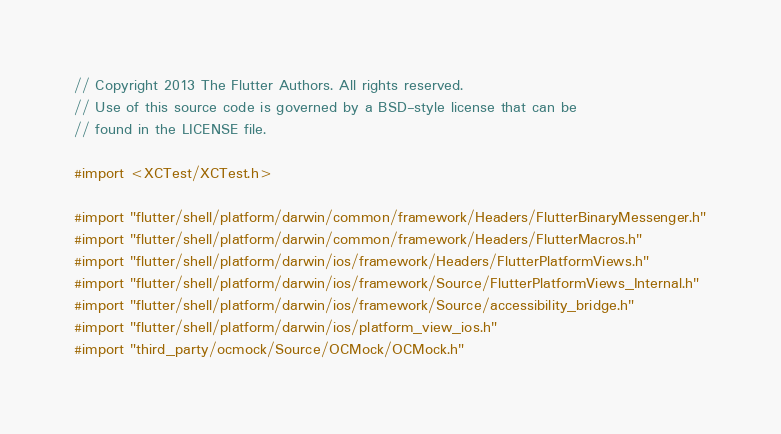<code> <loc_0><loc_0><loc_500><loc_500><_ObjectiveC_>// Copyright 2013 The Flutter Authors. All rights reserved.
// Use of this source code is governed by a BSD-style license that can be
// found in the LICENSE file.

#import <XCTest/XCTest.h>

#import "flutter/shell/platform/darwin/common/framework/Headers/FlutterBinaryMessenger.h"
#import "flutter/shell/platform/darwin/common/framework/Headers/FlutterMacros.h"
#import "flutter/shell/platform/darwin/ios/framework/Headers/FlutterPlatformViews.h"
#import "flutter/shell/platform/darwin/ios/framework/Source/FlutterPlatformViews_Internal.h"
#import "flutter/shell/platform/darwin/ios/framework/Source/accessibility_bridge.h"
#import "flutter/shell/platform/darwin/ios/platform_view_ios.h"
#import "third_party/ocmock/Source/OCMock/OCMock.h"
</code> 